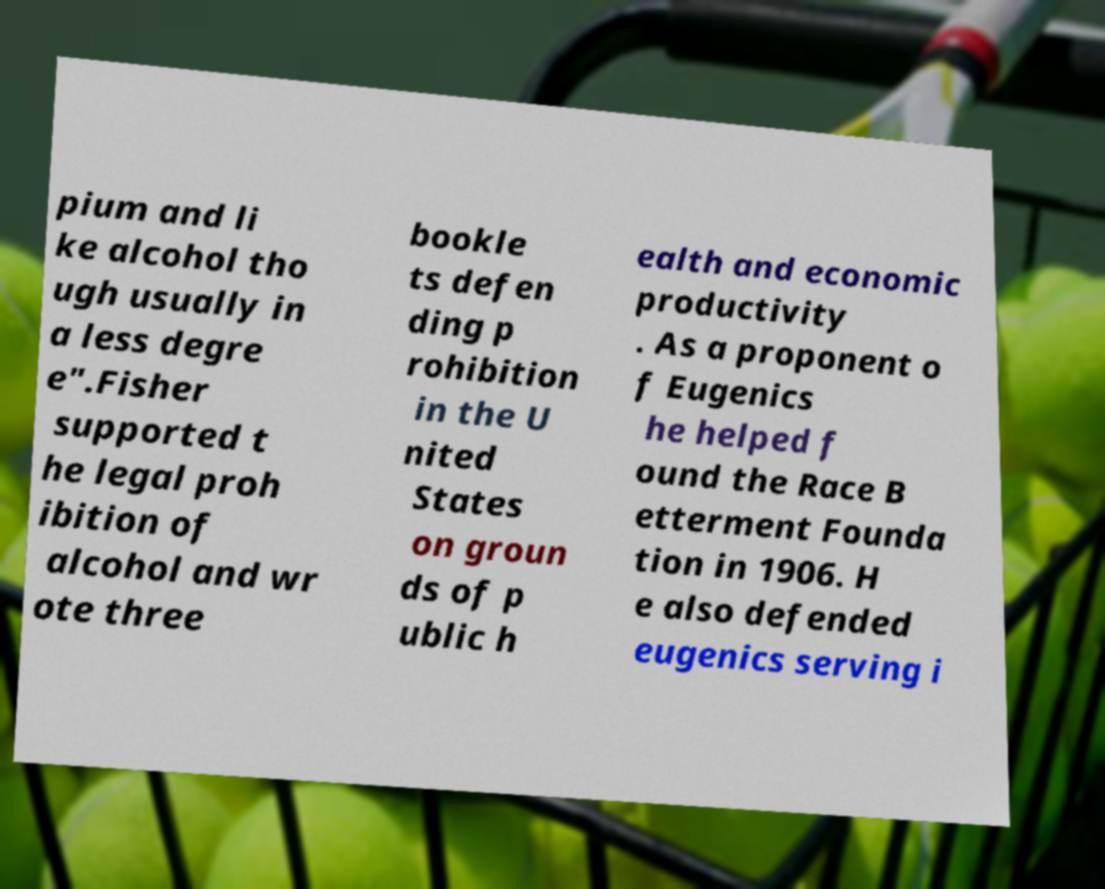Can you accurately transcribe the text from the provided image for me? pium and li ke alcohol tho ugh usually in a less degre e".Fisher supported t he legal proh ibition of alcohol and wr ote three bookle ts defen ding p rohibition in the U nited States on groun ds of p ublic h ealth and economic productivity . As a proponent o f Eugenics he helped f ound the Race B etterment Founda tion in 1906. H e also defended eugenics serving i 